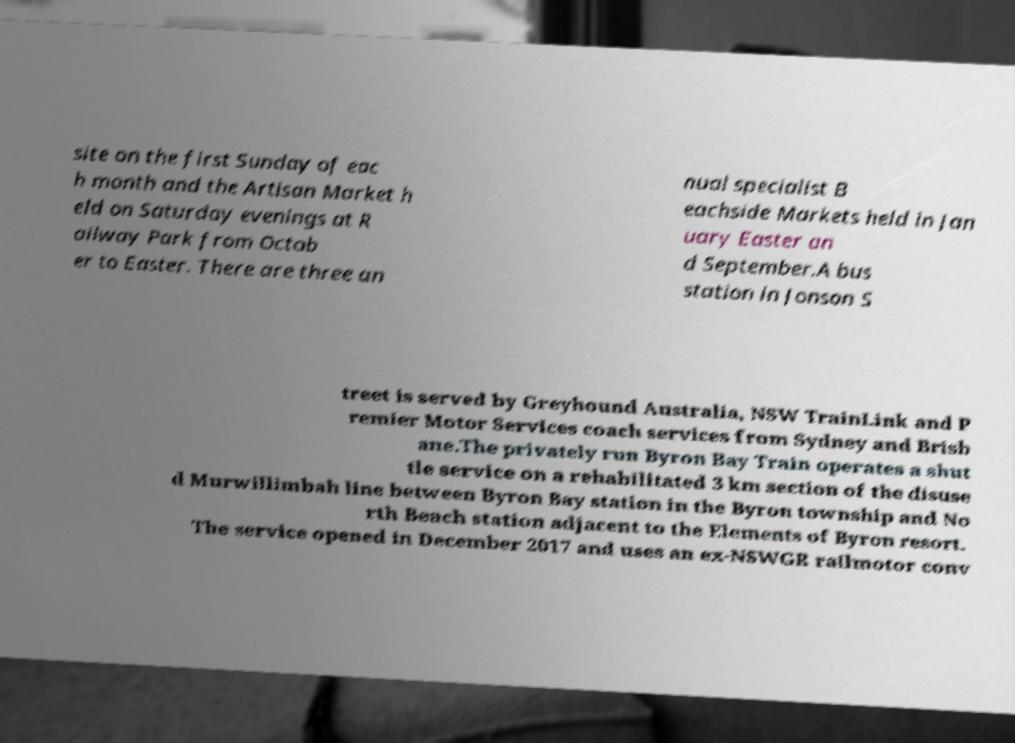Please read and relay the text visible in this image. What does it say? site on the first Sunday of eac h month and the Artisan Market h eld on Saturday evenings at R ailway Park from Octob er to Easter. There are three an nual specialist B eachside Markets held in Jan uary Easter an d September.A bus station in Jonson S treet is served by Greyhound Australia, NSW TrainLink and P remier Motor Services coach services from Sydney and Brisb ane.The privately run Byron Bay Train operates a shut tle service on a rehabilitated 3 km section of the disuse d Murwillimbah line between Byron Bay station in the Byron township and No rth Beach station adjacent to the Elements of Byron resort. The service opened in December 2017 and uses an ex-NSWGR railmotor conv 